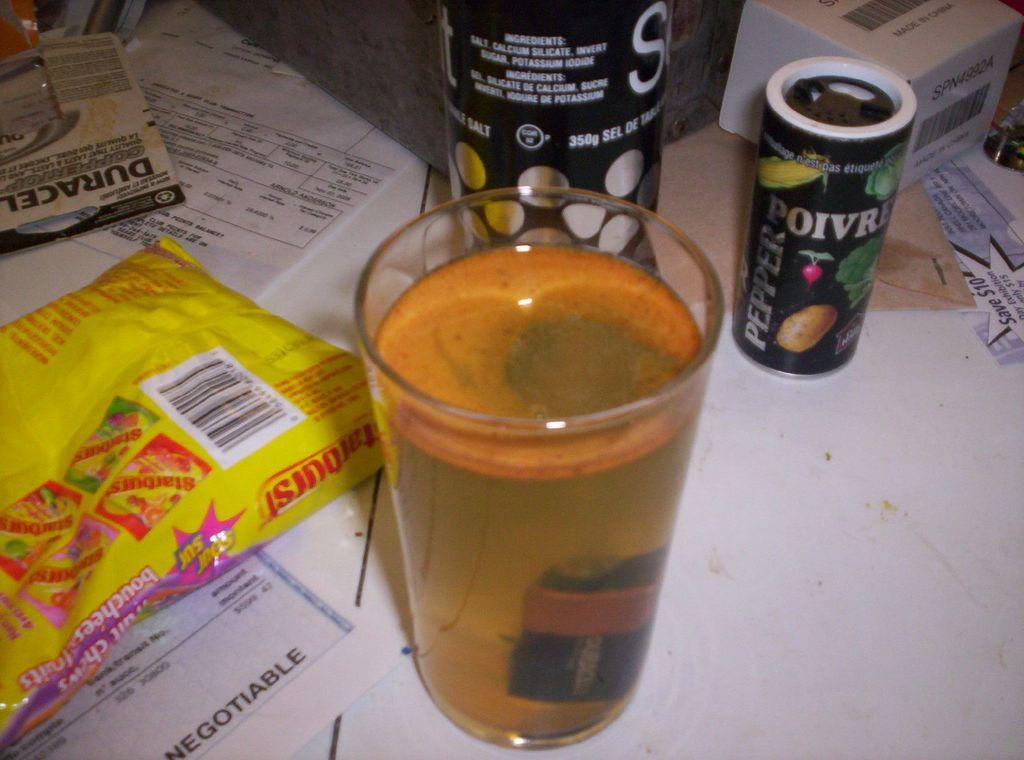<image>
Relay a brief, clear account of the picture shown. a glass of pale yellow liquid on a table with things like Pepper and Starburst 